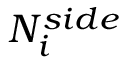Convert formula to latex. <formula><loc_0><loc_0><loc_500><loc_500>N _ { i } ^ { s i d e }</formula> 